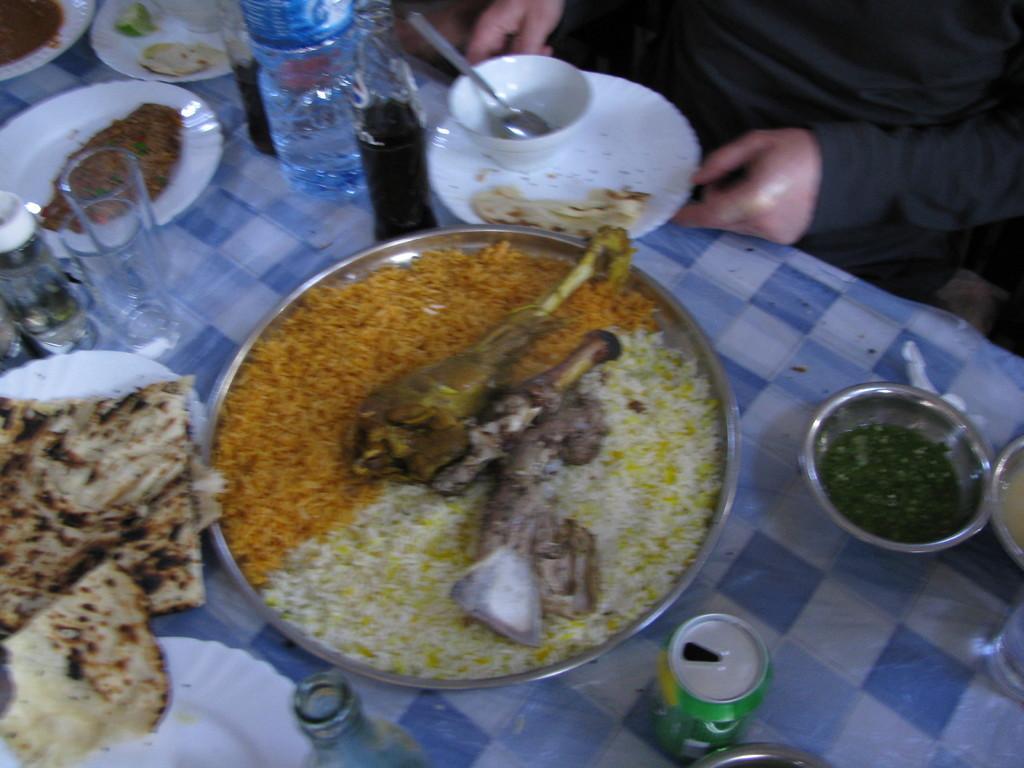Describe this image in one or two sentences. In the image we can see a person wearing clothes. In front of the person there is a table, on the table, we can see plate and food on the plate, bowl, spoon, glass, bottle, can and many other things. 